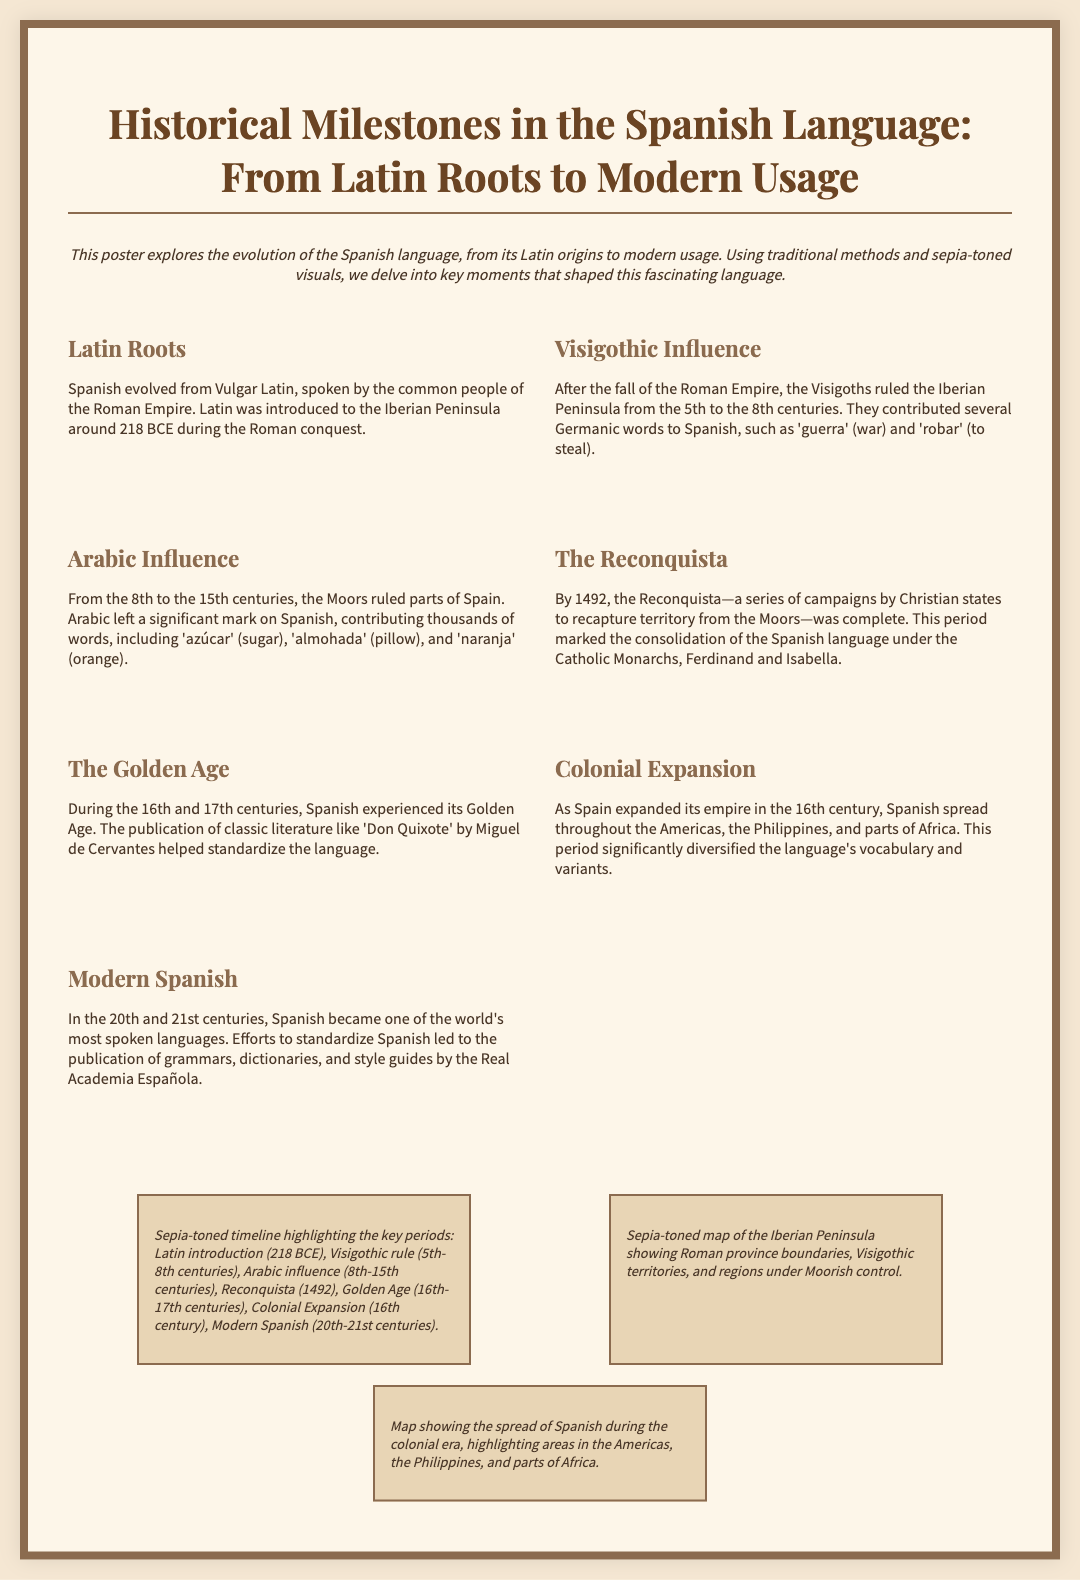What language did Spanish evolve from? Spanish evolved from Vulgar Latin, as stated in the section about Latin Roots.
Answer: Vulgar Latin What period did the Visigoths rule the Iberian Peninsula? The document states that the Visigoths ruled from the 5th to the 8th centuries.
Answer: 5th to 8th centuries What year marked the completion of the Reconquista? According to the section regarding the Reconquista, it was completed in the year 1492.
Answer: 1492 What significant event happened during the 16th and 17th centuries in Spanish history? The Golden Age is highlighted as a significant event during these centuries, noted in the corresponding section.
Answer: Golden Age Which two monarchs are mentioned in the context of the consolidation of the Spanish language? The document refers to Ferdinand and Isabella in connection with the consolidation of the Spanish language.
Answer: Ferdinand and Isabella What influence did the Moors have on the Spanish language? The document indicates that Arabic contributed thousands of words to Spanish during the Moorish rule.
Answer: Arabic words What is emphasized as a key element in standardizing modern Spanish? The publication of grammars, dictionaries, and style guides by the Real Academia Española is noted as a key element for standardization.
Answer: Real Academia Española What visual features are included in the poster regarding the historical timeline? The visuals detail a sepia-toned timeline and maps emphasizing various historical periods and influences on the Spanish language.
Answer: Sepia-toned timeline and maps Which territories are highlighted in the map of colonial expansion? The map shows areas in the Americas, the Philippines, and parts of Africa as highlighted during the colonial era.
Answer: Americas, Philippines, Africa 